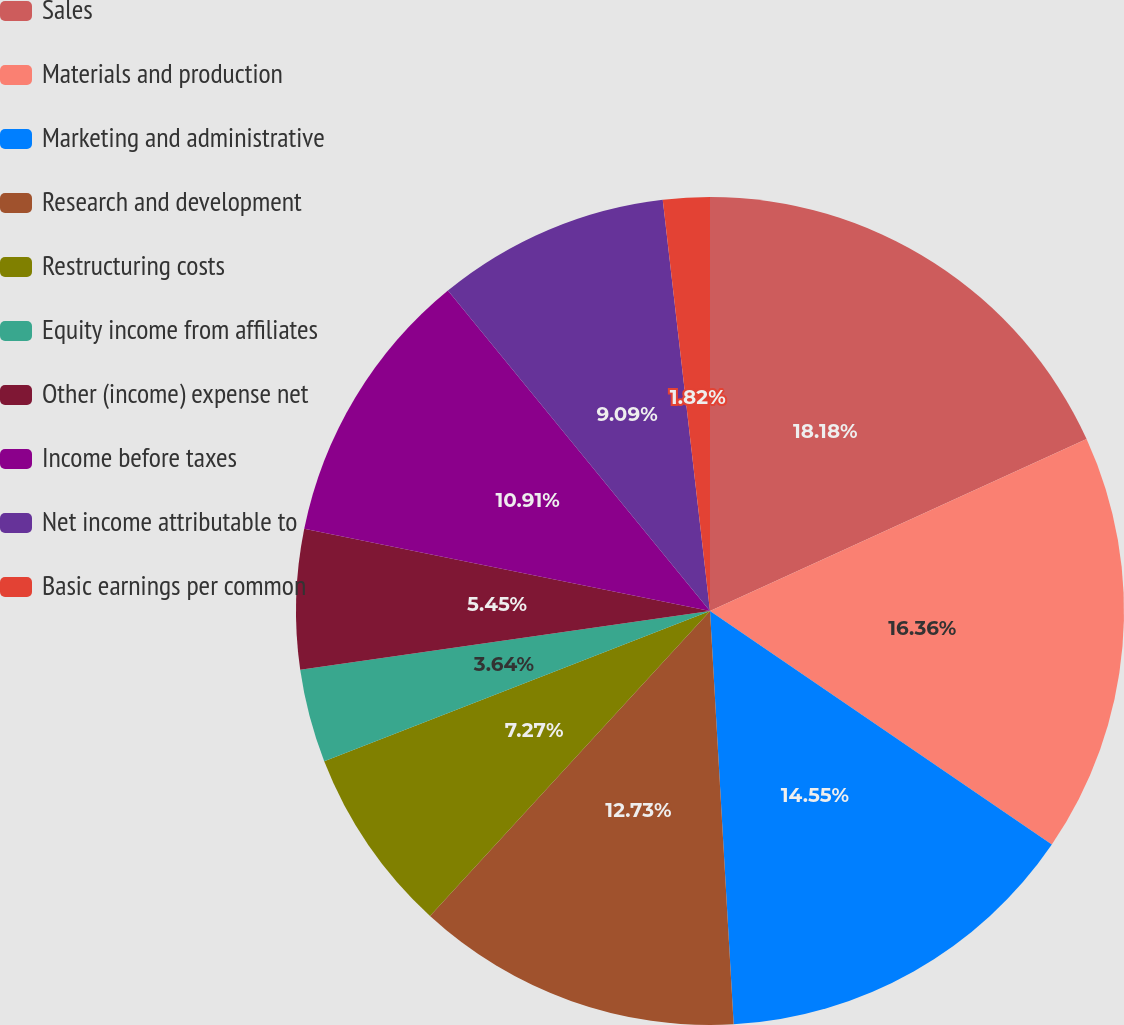<chart> <loc_0><loc_0><loc_500><loc_500><pie_chart><fcel>Sales<fcel>Materials and production<fcel>Marketing and administrative<fcel>Research and development<fcel>Restructuring costs<fcel>Equity income from affiliates<fcel>Other (income) expense net<fcel>Income before taxes<fcel>Net income attributable to<fcel>Basic earnings per common<nl><fcel>18.18%<fcel>16.36%<fcel>14.55%<fcel>12.73%<fcel>7.27%<fcel>3.64%<fcel>5.45%<fcel>10.91%<fcel>9.09%<fcel>1.82%<nl></chart> 